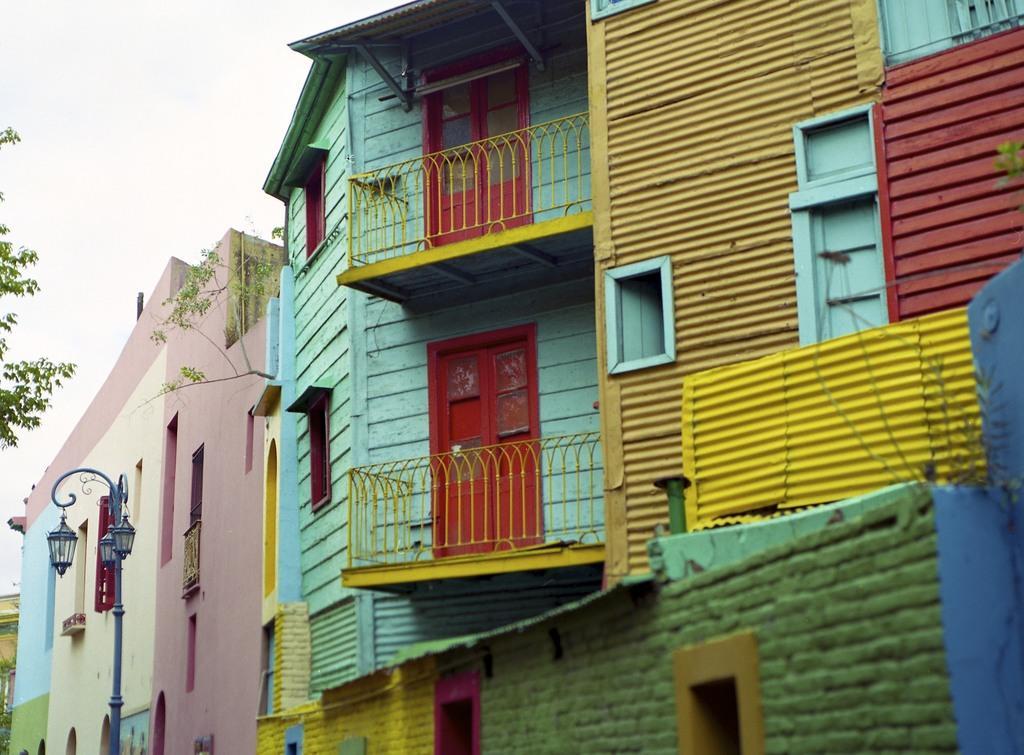Describe this image in one or two sentences. In this picture we can see buildings, railings, lights, pole and leaves. In the background of the image we can see the sky. 